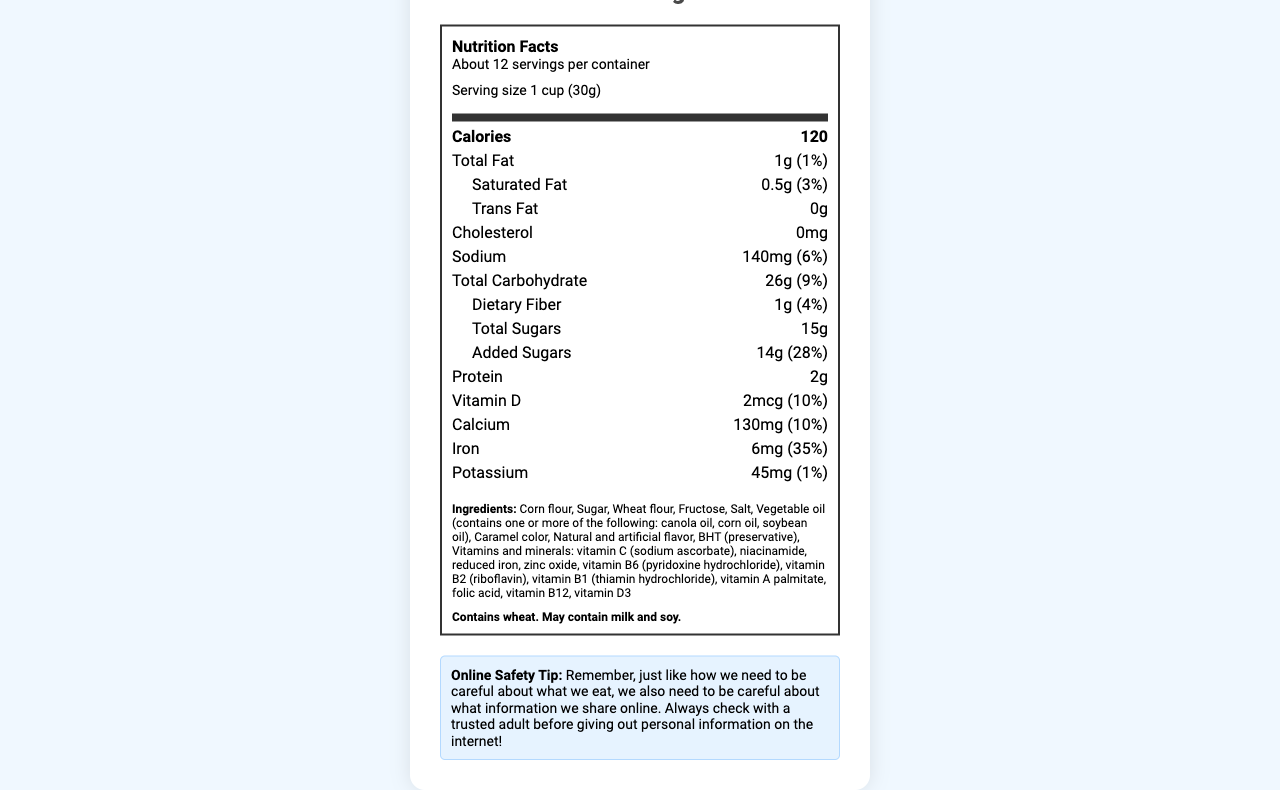what is the serving size for Sugar Blast-O's? The serving size is clearly stated at the top of the document as "1 cup (30g)".
Answer: 1 cup (30g) how many calories are in one serving of Sugar Blast-O's? The calories per serving are listed at the top in the bolded section.
Answer: 120 calories what is the percentage daily value of added sugars in a serving? Under added sugars, the document shows 14g, which is 28% of the daily value.
Answer: 28% how many grams of protein does one serving of Sugar Blast-O's contain? The amount of protein per serving is specified as 2g in the nutrition label.
Answer: 2g which ingredient is listed first in the ingredients list? The first ingredient listed in the document is Corn flour.
Answer: Corn flour how much iron is present in a serving? The document indicates that a serving contains 6mg of iron, which is 35% of the daily value.
Answer: 6mg (35% daily value) what kind of fats does Sugar Blast-O's contain? A. Saturated fat, Trans fat B. Total fat, Saturated fat C. Total fat, Trans fat D. Trans fat, Monounsaturated fat The document lists Total Fat as 1g and Saturated Fat as 0.5g.
Answer: B. Total fat, Saturated fat how many servings are in one container? I. 9 II. About 12 III. 1 IV. About 14 The document states that there are about 12 servings per container.
Answer: II. About 12 does the product contain any allergens? There is a section in bold that mentions it contains wheat and may contain milk and soy.
Answer: Yes summarize the main idea of this document. The document is a comprehensive nutrition facts label for Sugar Blast-O's, including all relevant nutritional information and additional details such as ingredients and allergens.
Answer: The document provides detailed nutrition facts for Sugar Blast-O's, a sugary breakfast cereal. It includes serving size, number of servings, calories, fats, carbohydrates, sugars, protein, vitamins, and minerals. It also lists ingredients, allergen information, and an online safety tip. how much dietary fiber is in a serving? The document mentions that each serving contains 1g of dietary fiber, which is 4% of the daily value.
Answer: 1g (4% daily value) who is the manufacturer of Sugar Blast-O's? The manufacturer is listed at the end of the document.
Answer: Sweetness Cereal Co. what is the sodium content per serving? The sodium content is provided as 140mg, which is 6% of the daily value.
Answer: 140mg (6% daily value) how does the document suggest practicing online safety? The online safety tip at the end of the document advises users to check with a trusted adult before sharing personal information online.
Answer: Always check with a trusted adult before giving out personal information. how many grams of total sugars are in a serving? The document indicates that there are 15g of total sugars in one serving.
Answer: 15g what kind of oil does the cereal contain? The ingredients list specifies that the vegetable oil may contain canola oil, corn oil, or soybean oil.
Answer: Vegetable oil (contains one or more of the following: canola oil, corn oil, soybean oil) what are the percentages of daily values for vitamin D and calcium? The document lists the daily values for Vitamin D and Calcium both as 10%.
Answer: Vitamin D: 10%, Calcium: 10% does Sugar Blast-O's contain any trans fat? The document states that the trans fat content is 0g.
Answer: No what is the amount of potassium in a serving? The potassium content per serving is 45mg, which is 1% of the daily value.
Answer: 45mg (1% daily value) does the cereal contain high fructose corn syrup? The ingredients list mentions "Fructose" but does not specify whether it is high fructose corn syrup.
Answer: Cannot be determined 